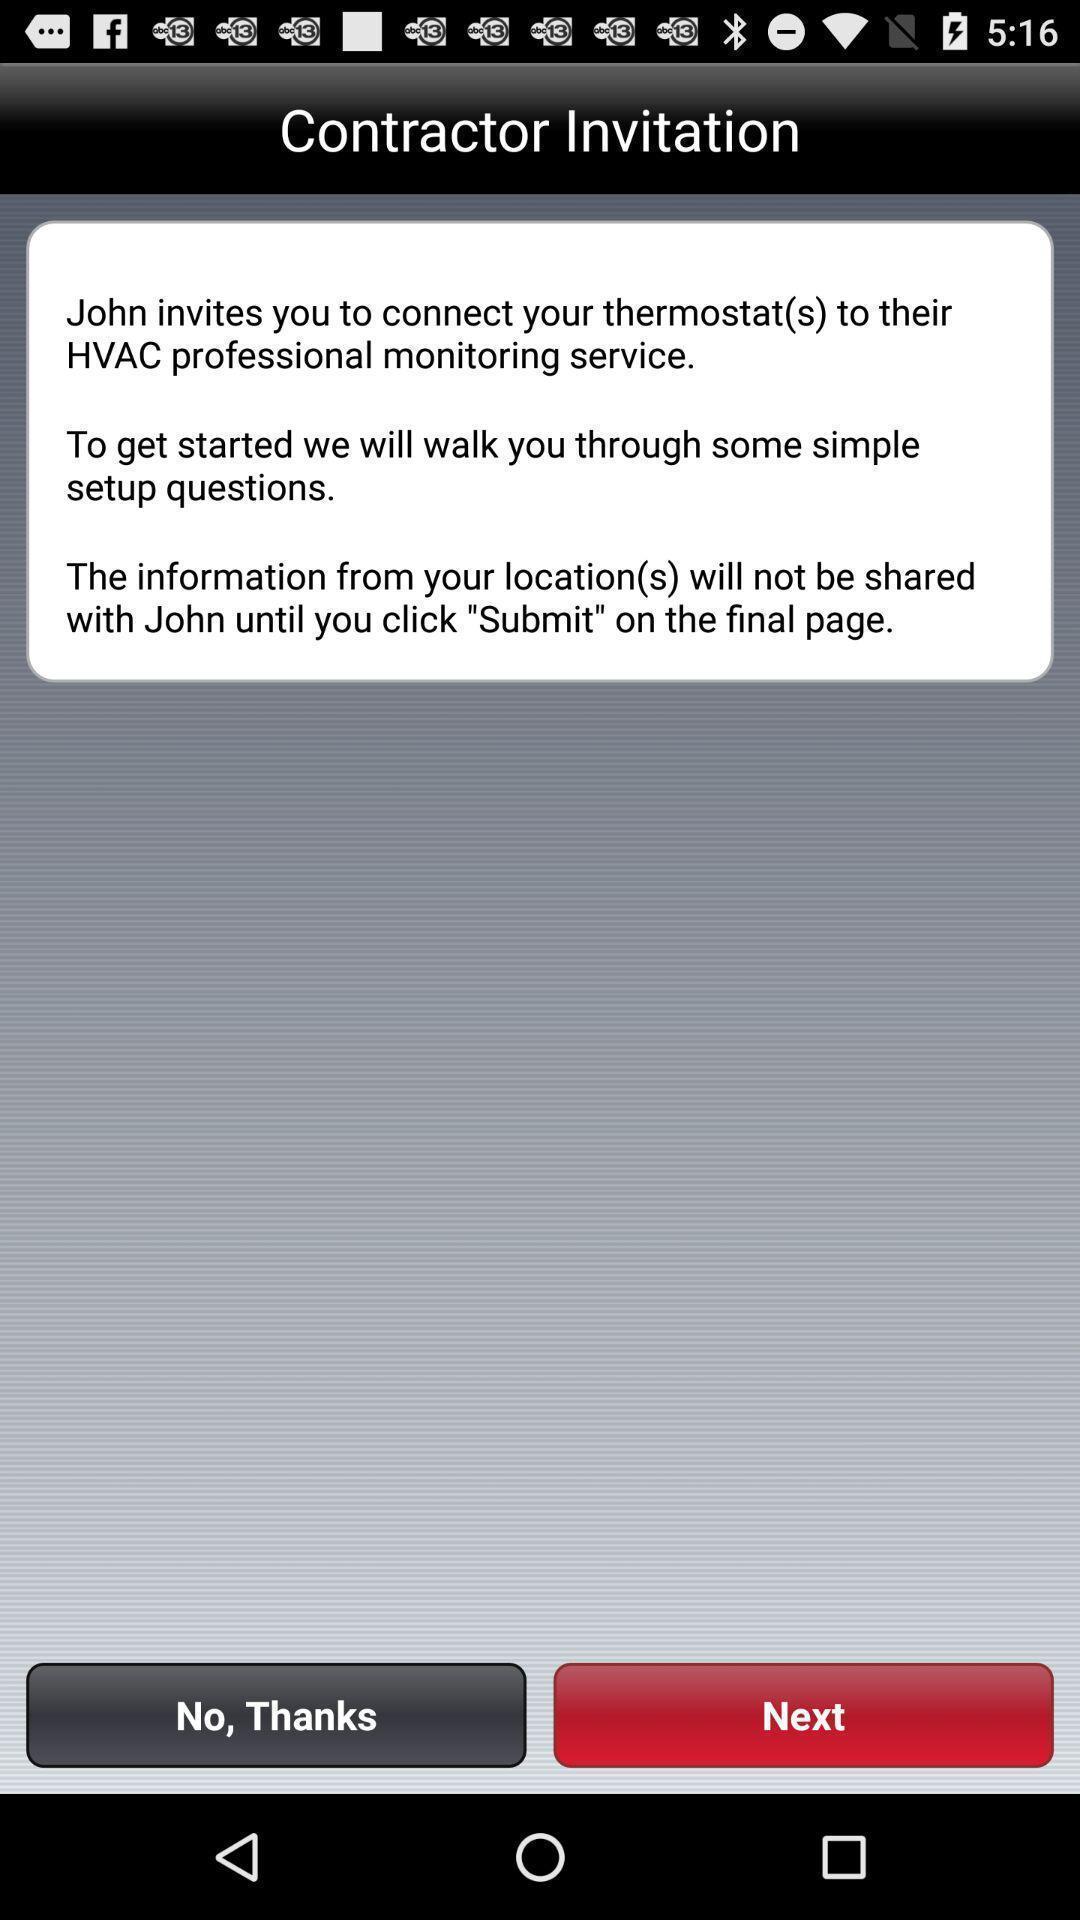Explain what's happening in this screen capture. Pop-up showing information about application. 